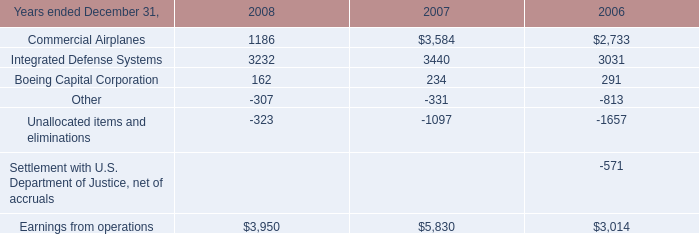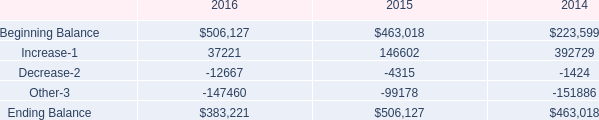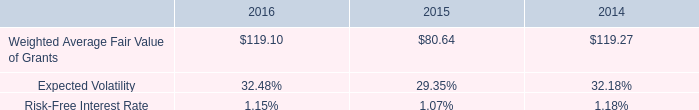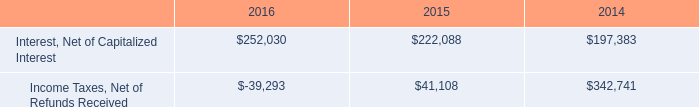What's the sum of Ending Balance of 2016, and Interest, Net of Capitalized Interest of 2014 ? 
Computations: (383221.0 + 197383.0)
Answer: 580604.0. 